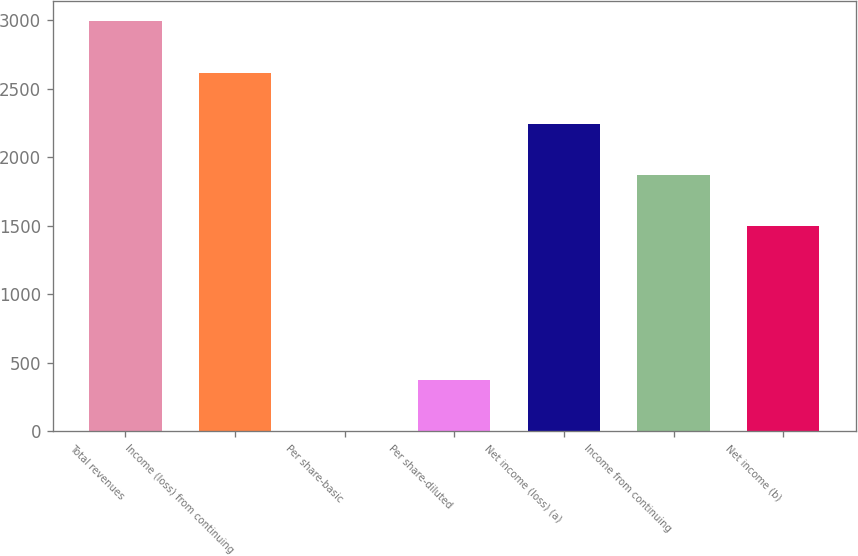Convert chart. <chart><loc_0><loc_0><loc_500><loc_500><bar_chart><fcel>Total revenues<fcel>Income (loss) from continuing<fcel>Per share-basic<fcel>Per share-diluted<fcel>Net income (loss) (a)<fcel>Income from continuing<fcel>Net income (b)<nl><fcel>2990.49<fcel>2616.72<fcel>0.33<fcel>374.1<fcel>2242.95<fcel>1869.18<fcel>1495.41<nl></chart> 